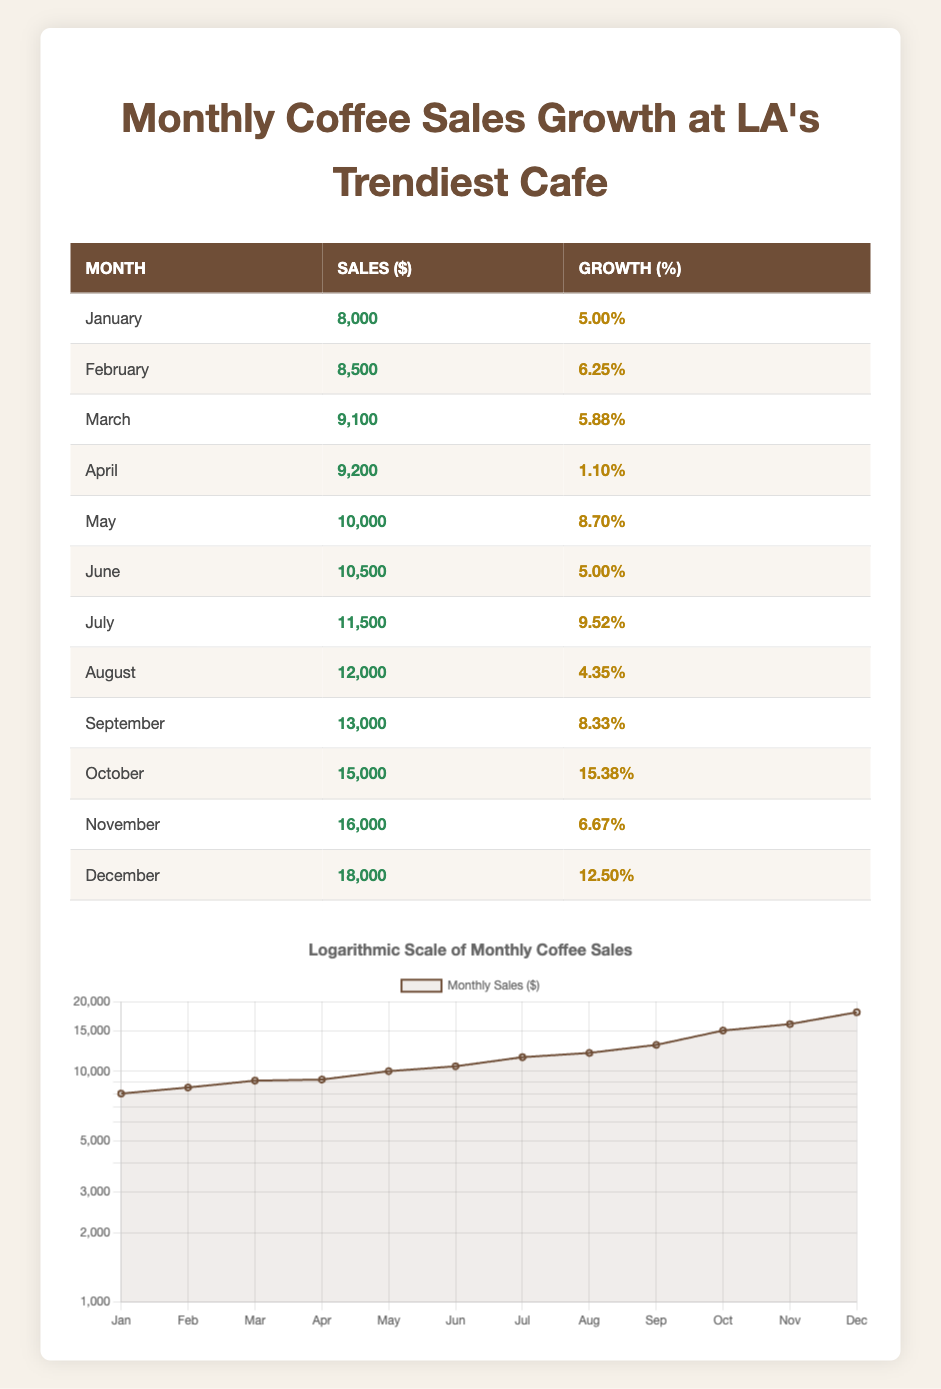What were the total sales in October? The table shows that the sales in October were 15,000 dollars.
Answer: 15,000 Which month had the highest sales growth percentage? By reviewing the growth percentages listed, October has the highest growth percentage of 15.38%.
Answer: October What is the average sales amount over the year? To find the average sales, we sum all monthly sales: 8000 + 8500 + 9100 + 9200 + 10000 + 10500 + 11500 + 12000 + 13000 + 15000 + 16000 + 18000 = 143,000. There are 12 months, so we divide 143,000 by 12, which equals approximately 11,916.67.
Answer: 11,916.67 Did sales increase every month? Analyzing the sales from month to month, there were decreases noted in April and August. Thus, sales did not increase every month.
Answer: No What was the growth percentage in April? According to the table, the growth percentage in April was 1.10%.
Answer: 1.10% Calculate the difference in sales between January and December. January sales were 8,000 and December's were 18,000. The difference is 18,000 - 8,000 = 10,000.
Answer: 10,000 Which month saw the lowest sales? A review of the sales amounts shows January had the lowest sales at 8,000.
Answer: January What is the total growth percentage from January to December? To find the total growth from January (0.05) to December (0.125), we calculate the total as 0.125 - 0.05 = 0.075 or 7.5%.
Answer: 7.5% In which month did sales increase by more than 10%? The entries indicate that only October (15.38%) and May (8.70%) had significant increases, but only October's growth was above 10%.
Answer: October 